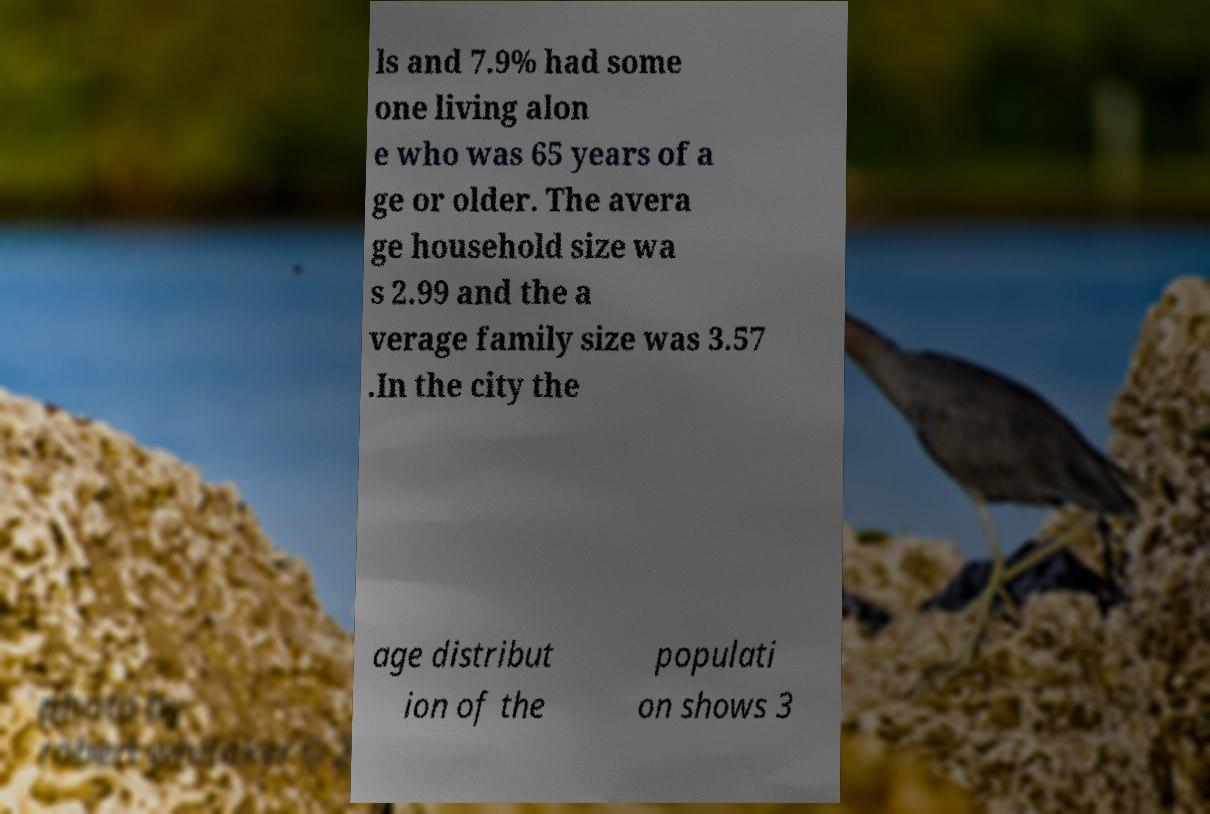I need the written content from this picture converted into text. Can you do that? ls and 7.9% had some one living alon e who was 65 years of a ge or older. The avera ge household size wa s 2.99 and the a verage family size was 3.57 .In the city the age distribut ion of the populati on shows 3 